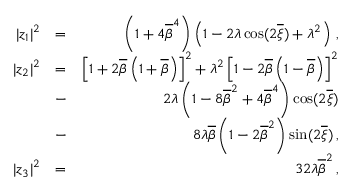Convert formula to latex. <formula><loc_0><loc_0><loc_500><loc_500>\begin{array} { r l r } { | z _ { 1 } | ^ { 2 } } & { = } & { \left ( 1 + 4 \overline { \beta } ^ { 4 } \right ) \left ( 1 - 2 \lambda \cos ( 2 \overline { \xi } ) + \lambda ^ { 2 } \right ) \, , } \\ { | z _ { 2 } | ^ { 2 } } & { = } & { \left [ 1 + 2 \overline { \beta } \left ( 1 + \overline { \beta } \right ) \right ] ^ { 2 } + \lambda ^ { 2 } \left [ 1 - 2 \overline { \beta } \left ( 1 - \overline { \beta } \right ) \right ] ^ { 2 } } \\ & { - } & { 2 \lambda \left ( 1 - 8 \overline { \beta } ^ { 2 } + 4 \overline { \beta } ^ { 4 } \right ) \cos ( 2 \overline { \xi } ) } \\ & { - } & { 8 \lambda \overline { \beta } \left ( 1 - 2 \overline { \beta } ^ { 2 } \right ) \sin ( 2 \overline { \xi } ) \, , } \\ { | z _ { 3 } | ^ { 2 } } & { = } & { 3 2 \lambda \overline { \beta } ^ { 2 } \, , } \end{array}</formula> 